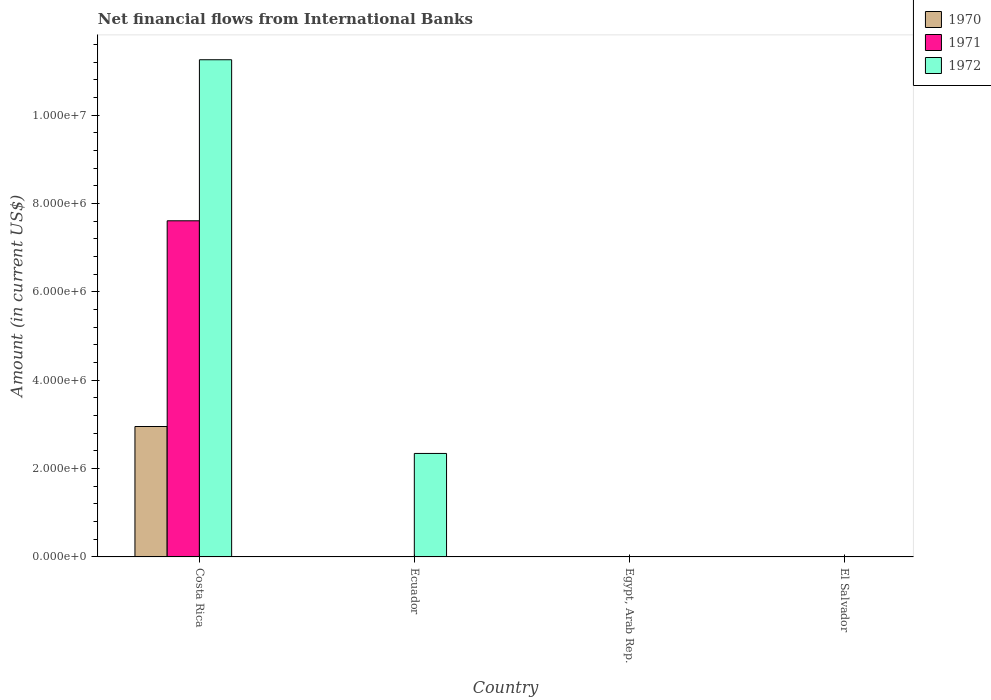Are the number of bars per tick equal to the number of legend labels?
Make the answer very short. No. What is the label of the 3rd group of bars from the left?
Your answer should be compact. Egypt, Arab Rep. In how many cases, is the number of bars for a given country not equal to the number of legend labels?
Provide a short and direct response. 3. Across all countries, what is the maximum net financial aid flows in 1970?
Give a very brief answer. 2.95e+06. Across all countries, what is the minimum net financial aid flows in 1970?
Your answer should be compact. 0. In which country was the net financial aid flows in 1971 maximum?
Your response must be concise. Costa Rica. What is the total net financial aid flows in 1970 in the graph?
Your response must be concise. 2.95e+06. What is the difference between the net financial aid flows in 1972 in Costa Rica and that in Ecuador?
Your answer should be compact. 8.91e+06. What is the difference between the net financial aid flows in 1971 in El Salvador and the net financial aid flows in 1972 in Ecuador?
Offer a very short reply. -2.34e+06. What is the average net financial aid flows in 1970 per country?
Provide a succinct answer. 7.38e+05. What is the difference between the net financial aid flows of/in 1972 and net financial aid flows of/in 1971 in Costa Rica?
Provide a succinct answer. 3.64e+06. In how many countries, is the net financial aid flows in 1971 greater than 3200000 US$?
Your answer should be very brief. 1. What is the ratio of the net financial aid flows in 1972 in Costa Rica to that in Ecuador?
Ensure brevity in your answer.  4.8. What is the difference between the highest and the lowest net financial aid flows in 1972?
Provide a short and direct response. 1.13e+07. In how many countries, is the net financial aid flows in 1972 greater than the average net financial aid flows in 1972 taken over all countries?
Your response must be concise. 1. Is it the case that in every country, the sum of the net financial aid flows in 1970 and net financial aid flows in 1971 is greater than the net financial aid flows in 1972?
Your answer should be very brief. No. How many bars are there?
Your response must be concise. 4. Are all the bars in the graph horizontal?
Offer a very short reply. No. How many countries are there in the graph?
Offer a very short reply. 4. Are the values on the major ticks of Y-axis written in scientific E-notation?
Provide a short and direct response. Yes. Does the graph contain any zero values?
Your response must be concise. Yes. Does the graph contain grids?
Give a very brief answer. No. How many legend labels are there?
Offer a very short reply. 3. How are the legend labels stacked?
Keep it short and to the point. Vertical. What is the title of the graph?
Your answer should be very brief. Net financial flows from International Banks. Does "2007" appear as one of the legend labels in the graph?
Provide a short and direct response. No. What is the Amount (in current US$) in 1970 in Costa Rica?
Offer a terse response. 2.95e+06. What is the Amount (in current US$) of 1971 in Costa Rica?
Make the answer very short. 7.61e+06. What is the Amount (in current US$) in 1972 in Costa Rica?
Ensure brevity in your answer.  1.13e+07. What is the Amount (in current US$) of 1972 in Ecuador?
Your answer should be very brief. 2.34e+06. What is the Amount (in current US$) of 1970 in El Salvador?
Provide a succinct answer. 0. What is the Amount (in current US$) in 1972 in El Salvador?
Your response must be concise. 0. Across all countries, what is the maximum Amount (in current US$) of 1970?
Provide a short and direct response. 2.95e+06. Across all countries, what is the maximum Amount (in current US$) in 1971?
Keep it short and to the point. 7.61e+06. Across all countries, what is the maximum Amount (in current US$) in 1972?
Your response must be concise. 1.13e+07. Across all countries, what is the minimum Amount (in current US$) in 1970?
Your answer should be compact. 0. Across all countries, what is the minimum Amount (in current US$) of 1972?
Offer a very short reply. 0. What is the total Amount (in current US$) in 1970 in the graph?
Provide a short and direct response. 2.95e+06. What is the total Amount (in current US$) of 1971 in the graph?
Keep it short and to the point. 7.61e+06. What is the total Amount (in current US$) of 1972 in the graph?
Provide a short and direct response. 1.36e+07. What is the difference between the Amount (in current US$) of 1972 in Costa Rica and that in Ecuador?
Provide a short and direct response. 8.91e+06. What is the difference between the Amount (in current US$) of 1970 in Costa Rica and the Amount (in current US$) of 1972 in Ecuador?
Provide a succinct answer. 6.10e+05. What is the difference between the Amount (in current US$) of 1971 in Costa Rica and the Amount (in current US$) of 1972 in Ecuador?
Make the answer very short. 5.27e+06. What is the average Amount (in current US$) in 1970 per country?
Your answer should be compact. 7.38e+05. What is the average Amount (in current US$) of 1971 per country?
Offer a very short reply. 1.90e+06. What is the average Amount (in current US$) in 1972 per country?
Offer a very short reply. 3.40e+06. What is the difference between the Amount (in current US$) of 1970 and Amount (in current US$) of 1971 in Costa Rica?
Your answer should be very brief. -4.66e+06. What is the difference between the Amount (in current US$) in 1970 and Amount (in current US$) in 1972 in Costa Rica?
Keep it short and to the point. -8.30e+06. What is the difference between the Amount (in current US$) in 1971 and Amount (in current US$) in 1972 in Costa Rica?
Offer a very short reply. -3.64e+06. What is the ratio of the Amount (in current US$) in 1972 in Costa Rica to that in Ecuador?
Ensure brevity in your answer.  4.8. What is the difference between the highest and the lowest Amount (in current US$) of 1970?
Offer a very short reply. 2.95e+06. What is the difference between the highest and the lowest Amount (in current US$) in 1971?
Your answer should be compact. 7.61e+06. What is the difference between the highest and the lowest Amount (in current US$) of 1972?
Make the answer very short. 1.13e+07. 